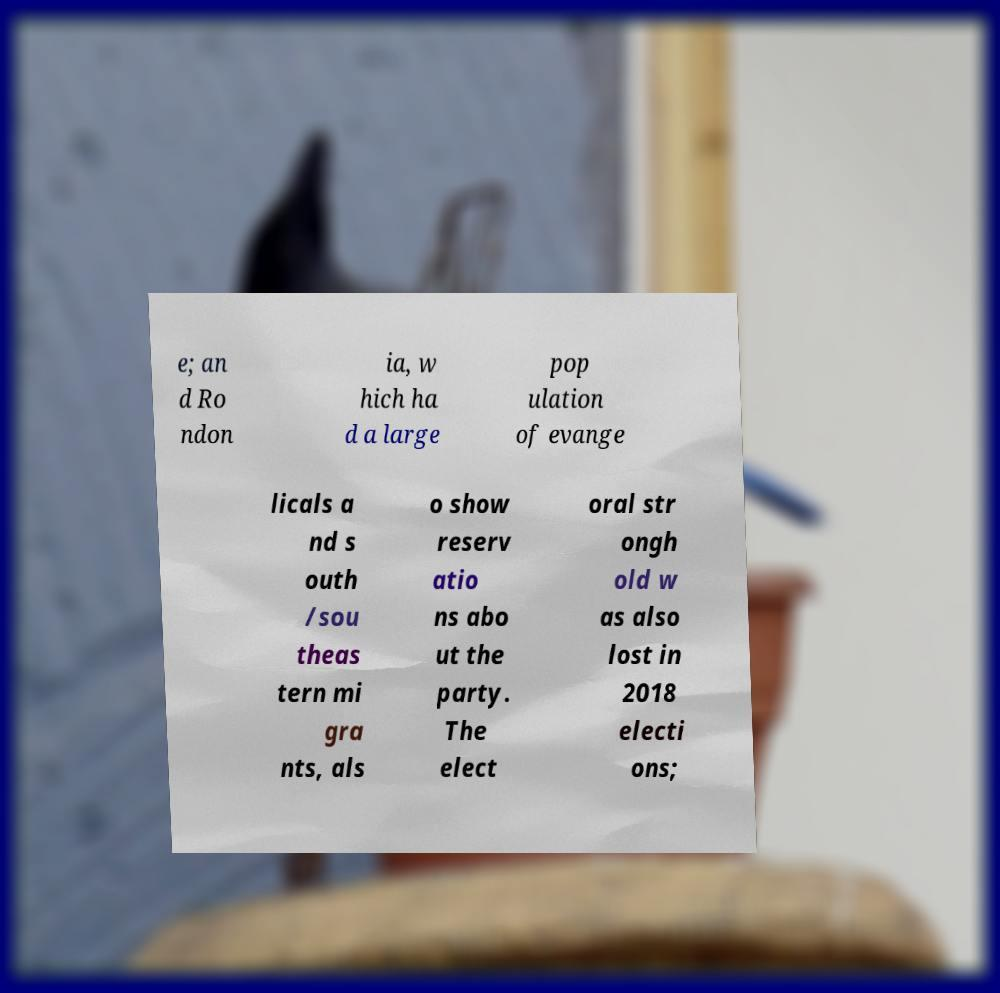Could you assist in decoding the text presented in this image and type it out clearly? e; an d Ro ndon ia, w hich ha d a large pop ulation of evange licals a nd s outh /sou theas tern mi gra nts, als o show reserv atio ns abo ut the party. The elect oral str ongh old w as also lost in 2018 electi ons; 